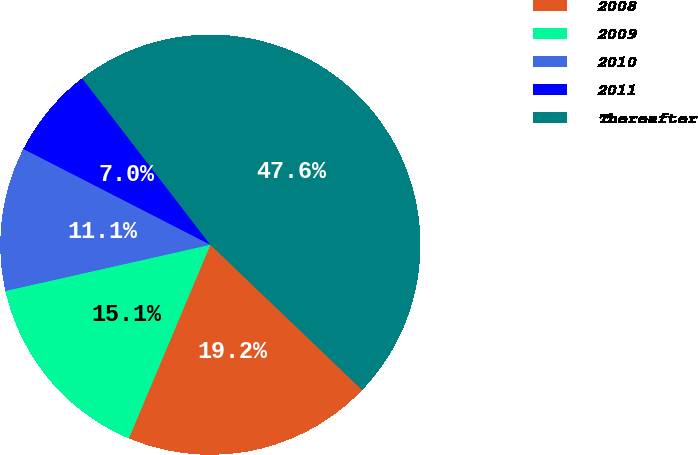Convert chart. <chart><loc_0><loc_0><loc_500><loc_500><pie_chart><fcel>2008<fcel>2009<fcel>2010<fcel>2011<fcel>Thereafter<nl><fcel>19.19%<fcel>15.13%<fcel>11.07%<fcel>7.02%<fcel>47.59%<nl></chart> 